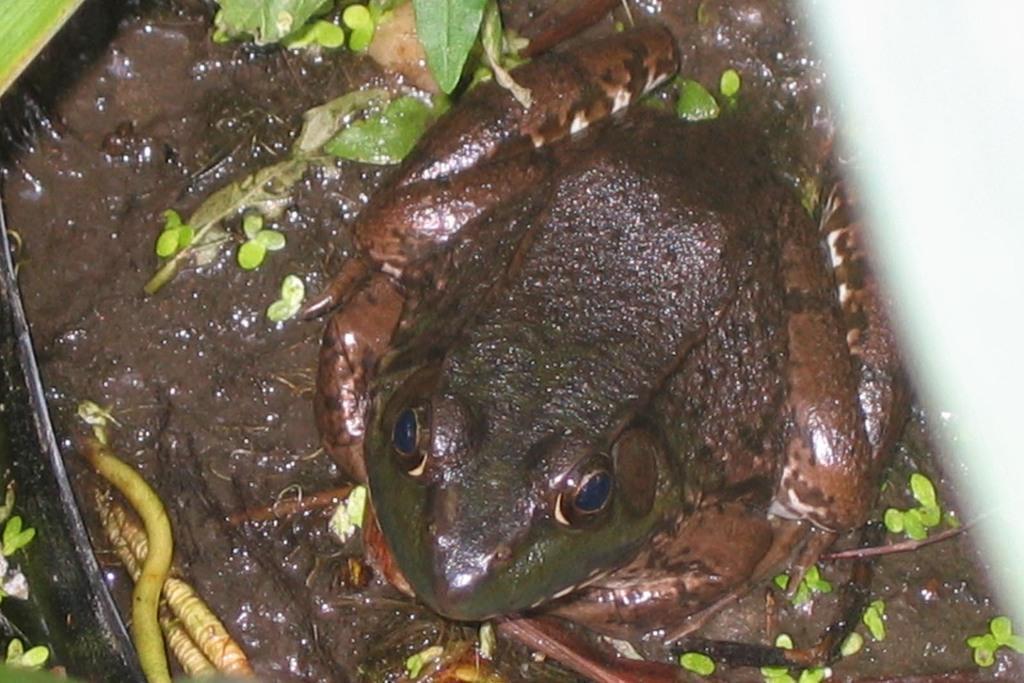Please provide a concise description of this image. In this image there is a frog and few animals are on the mud having few plants on it. 